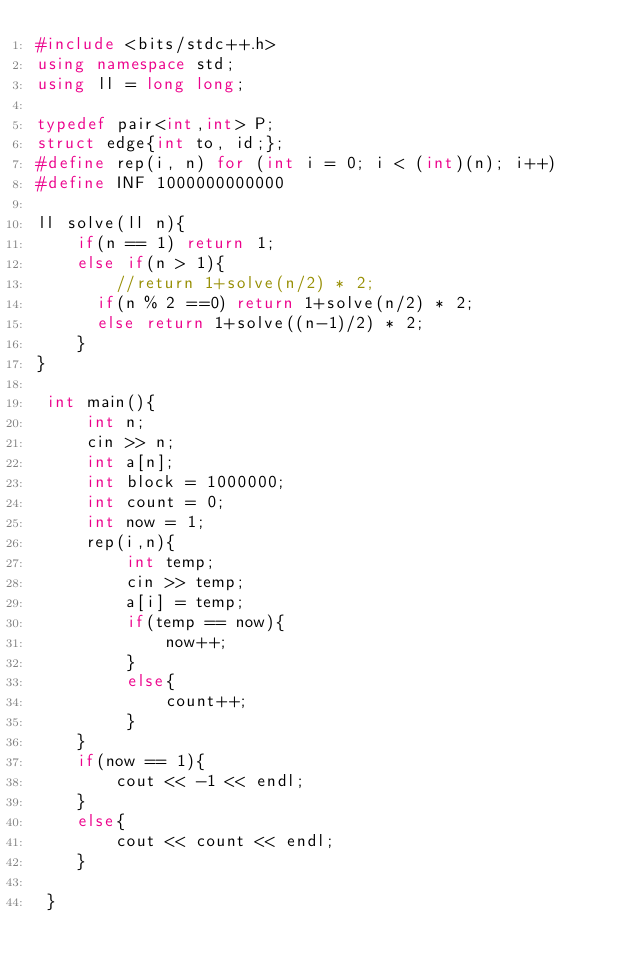<code> <loc_0><loc_0><loc_500><loc_500><_C++_>#include <bits/stdc++.h>
using namespace std;
using ll = long long;
 
typedef pair<int,int> P;
struct edge{int to, id;};
#define rep(i, n) for (int i = 0; i < (int)(n); i++)
#define INF 1000000000000
 
ll solve(ll n){
    if(n == 1) return 1;
    else if(n > 1){
        //return 1+solve(n/2) * 2;
      if(n % 2 ==0) return 1+solve(n/2) * 2;
      else return 1+solve((n-1)/2) * 2;
    }
}
 
 int main(){
     int n;
     cin >> n;
     int a[n];
     int block = 1000000;
     int count = 0;
     int now = 1;
     rep(i,n){
         int temp;
         cin >> temp;
         a[i] = temp;
         if(temp == now){
             now++;
         }
         else{
             count++;
         }
    }
    if(now == 1){
        cout << -1 << endl;
    }
    else{
        cout << count << endl;
    }
 
 }</code> 